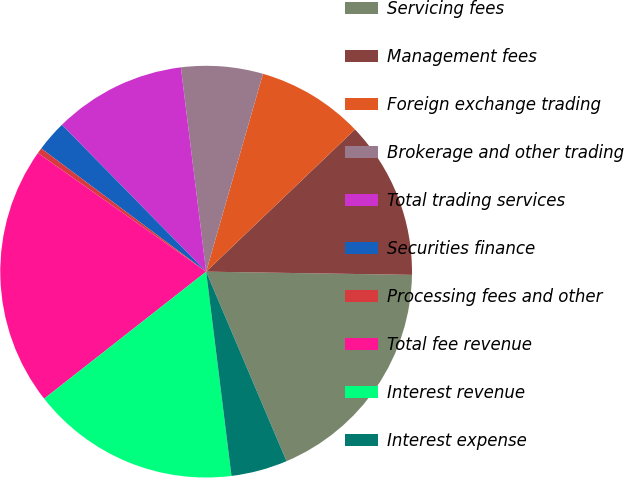Convert chart to OTSL. <chart><loc_0><loc_0><loc_500><loc_500><pie_chart><fcel>Servicing fees<fcel>Management fees<fcel>Foreign exchange trading<fcel>Brokerage and other trading<fcel>Total trading services<fcel>Securities finance<fcel>Processing fees and other<fcel>Total fee revenue<fcel>Interest revenue<fcel>Interest expense<nl><fcel>18.37%<fcel>12.39%<fcel>8.41%<fcel>6.41%<fcel>10.4%<fcel>2.43%<fcel>0.44%<fcel>20.36%<fcel>16.38%<fcel>4.42%<nl></chart> 